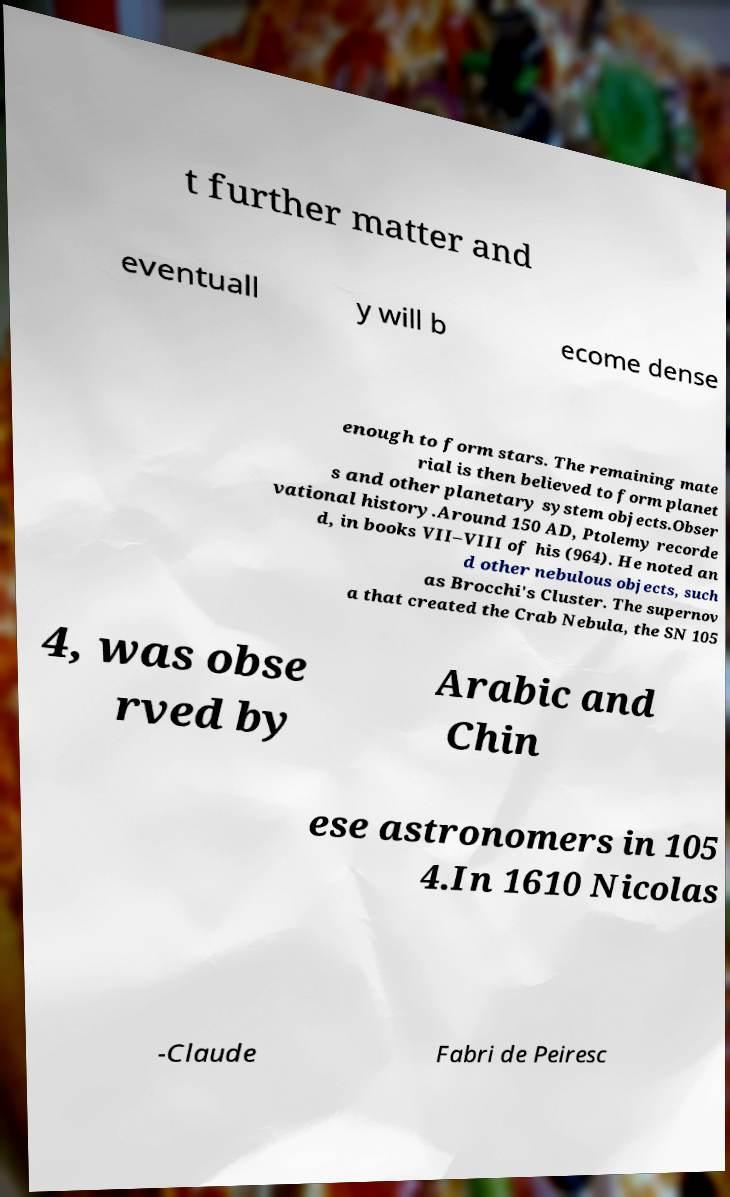Please read and relay the text visible in this image. What does it say? t further matter and eventuall y will b ecome dense enough to form stars. The remaining mate rial is then believed to form planet s and other planetary system objects.Obser vational history.Around 150 AD, Ptolemy recorde d, in books VII–VIII of his (964). He noted an d other nebulous objects, such as Brocchi's Cluster. The supernov a that created the Crab Nebula, the SN 105 4, was obse rved by Arabic and Chin ese astronomers in 105 4.In 1610 Nicolas -Claude Fabri de Peiresc 